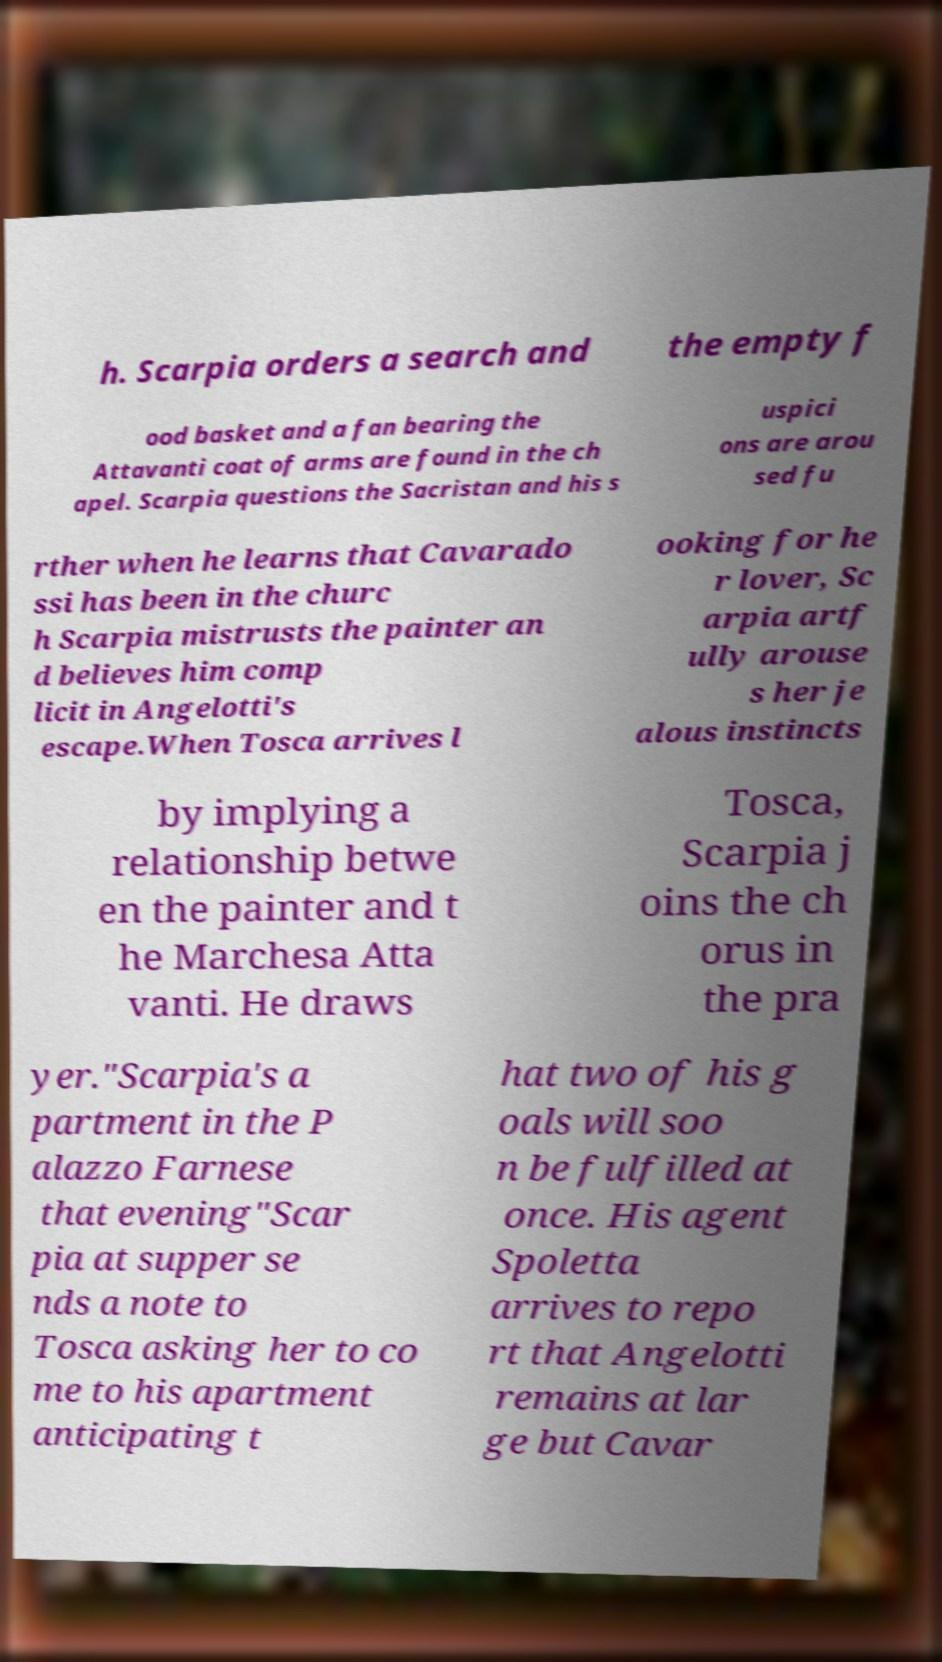What messages or text are displayed in this image? I need them in a readable, typed format. h. Scarpia orders a search and the empty f ood basket and a fan bearing the Attavanti coat of arms are found in the ch apel. Scarpia questions the Sacristan and his s uspici ons are arou sed fu rther when he learns that Cavarado ssi has been in the churc h Scarpia mistrusts the painter an d believes him comp licit in Angelotti's escape.When Tosca arrives l ooking for he r lover, Sc arpia artf ully arouse s her je alous instincts by implying a relationship betwe en the painter and t he Marchesa Atta vanti. He draws Tosca, Scarpia j oins the ch orus in the pra yer."Scarpia's a partment in the P alazzo Farnese that evening"Scar pia at supper se nds a note to Tosca asking her to co me to his apartment anticipating t hat two of his g oals will soo n be fulfilled at once. His agent Spoletta arrives to repo rt that Angelotti remains at lar ge but Cavar 